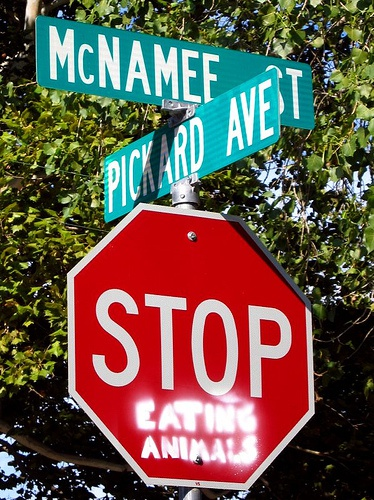Describe the objects in this image and their specific colors. I can see a stop sign in black, brown, lightgray, and lightpink tones in this image. 